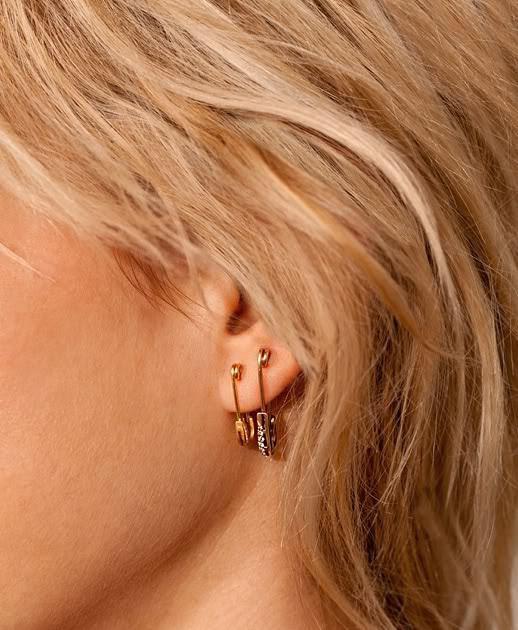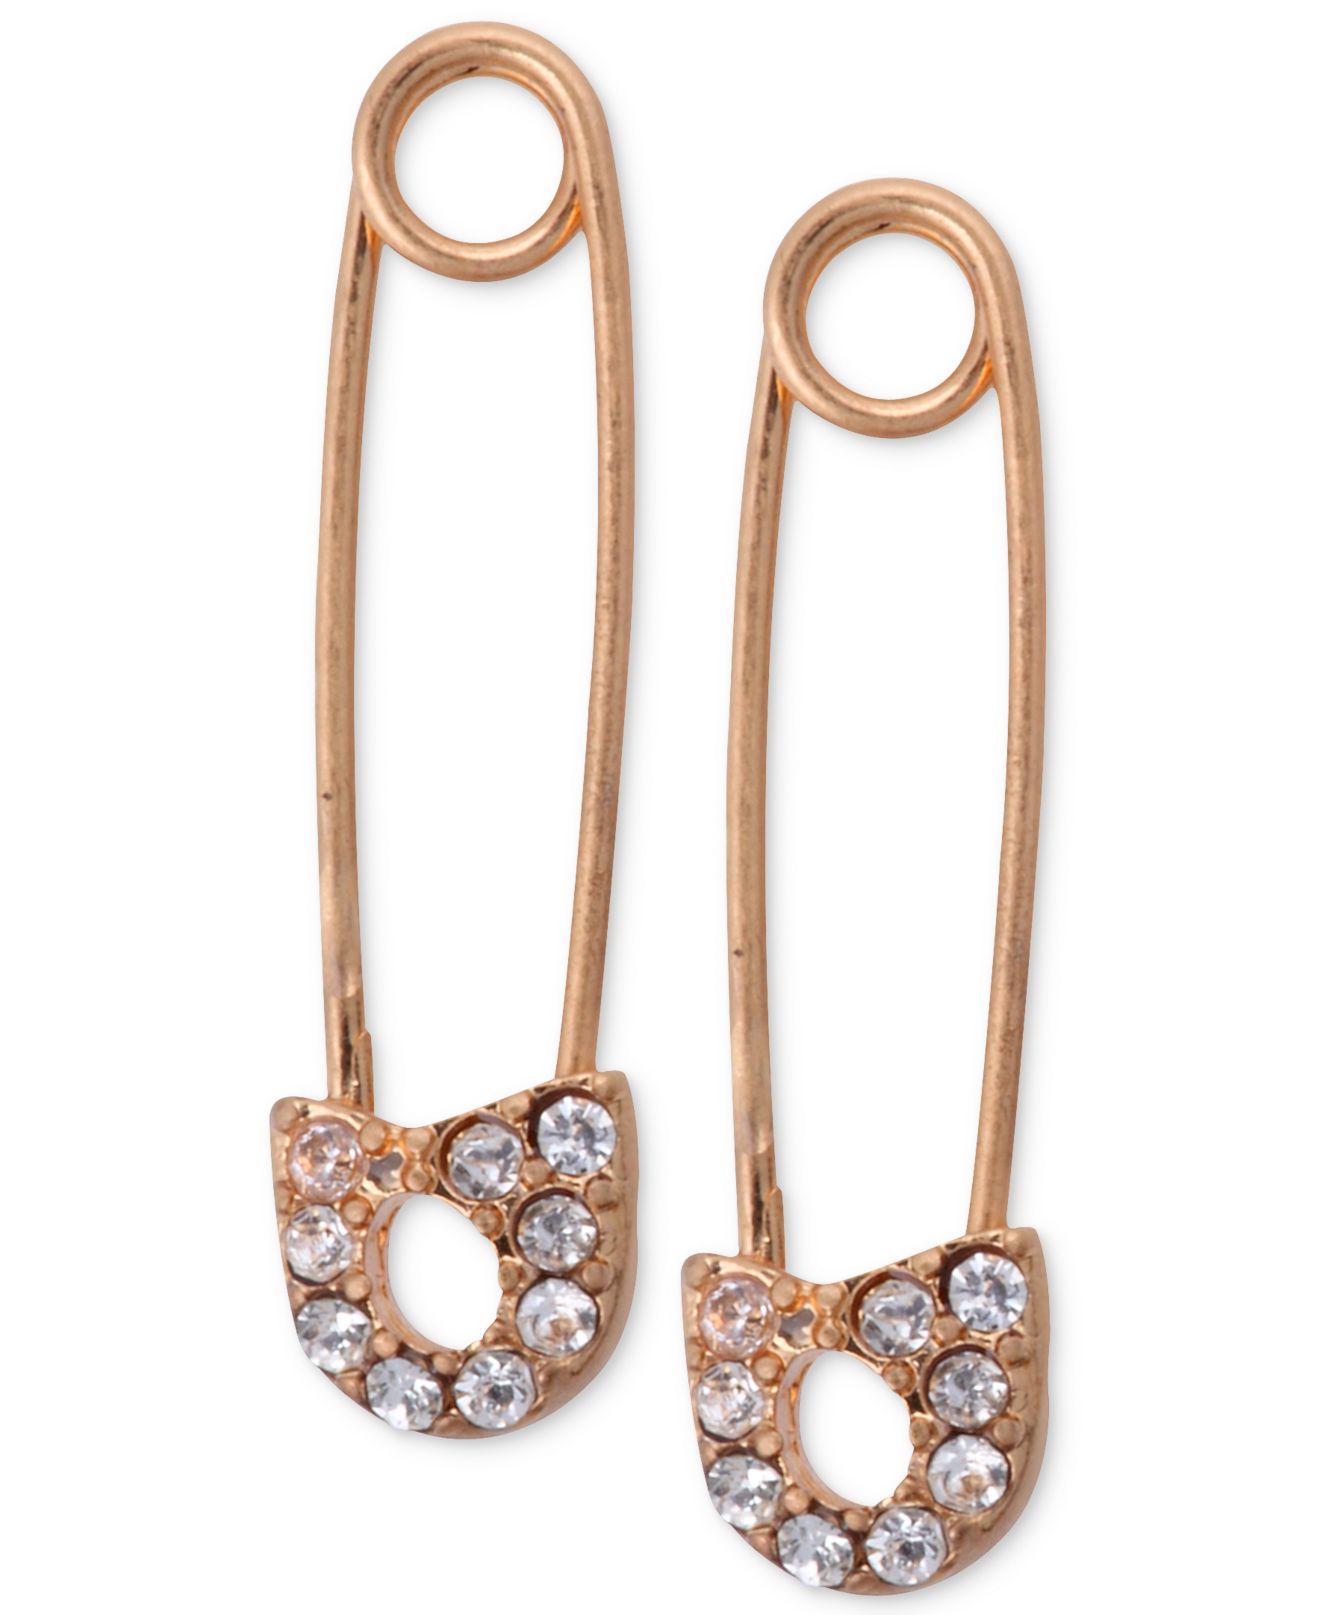The first image is the image on the left, the second image is the image on the right. Analyze the images presented: Is the assertion "A person is wearing a safety pin in their ear in the image on the left." valid? Answer yes or no. Yes. The first image is the image on the left, the second image is the image on the right. Analyze the images presented: Is the assertion "The left image contains a women wearing an ear ring." valid? Answer yes or no. Yes. 